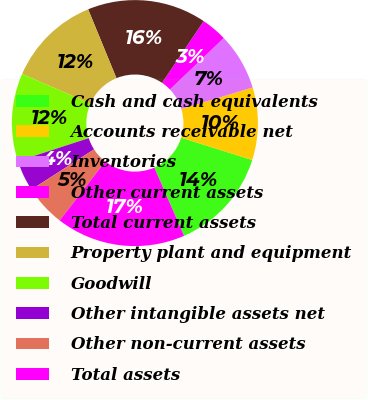<chart> <loc_0><loc_0><loc_500><loc_500><pie_chart><fcel>Cash and cash equivalents<fcel>Accounts receivable net<fcel>Inventories<fcel>Other current assets<fcel>Total current assets<fcel>Property plant and equipment<fcel>Goodwill<fcel>Other intangible assets net<fcel>Other non-current assets<fcel>Total assets<nl><fcel>13.6%<fcel>9.52%<fcel>7.48%<fcel>3.4%<fcel>15.65%<fcel>12.24%<fcel>11.56%<fcel>4.08%<fcel>5.44%<fcel>17.01%<nl></chart> 